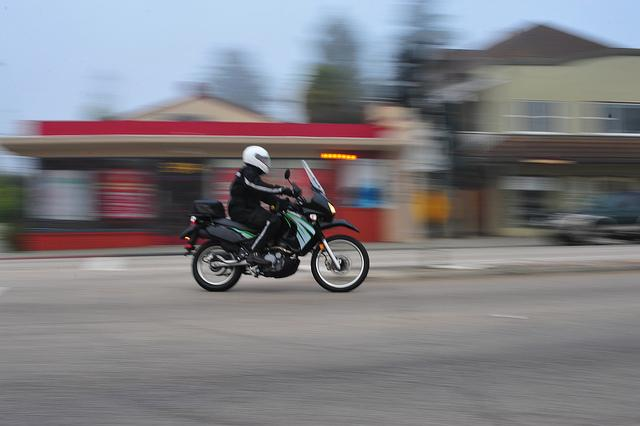Why is the man wearing a white helmet?

Choices:
A) protection
B) visibility
C) dress code
D) fashion protection 